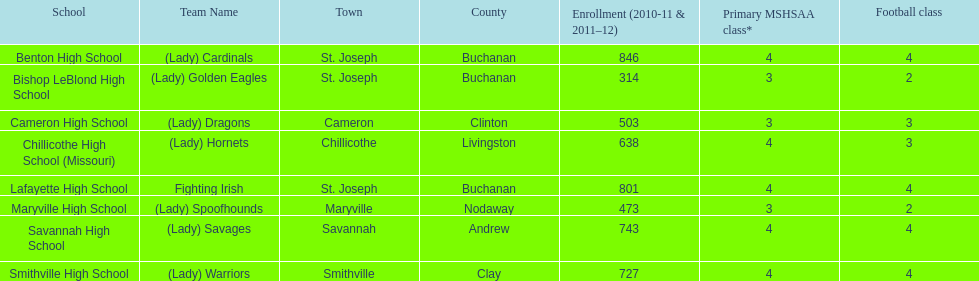In which school is the largest population of enrolled students? Benton High School. 